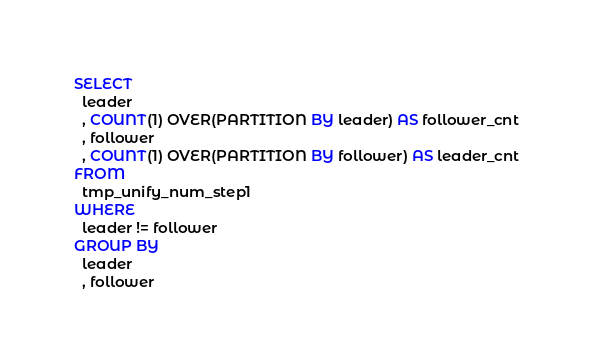Convert code to text. <code><loc_0><loc_0><loc_500><loc_500><_SQL_>SELECT
  leader
  , COUNT(1) OVER(PARTITION BY leader) AS follower_cnt
  , follower
  , COUNT(1) OVER(PARTITION BY follower) AS leader_cnt
FROM
  tmp_unify_num_step1
WHERE
  leader != follower
GROUP BY
  leader
  , follower
</code> 